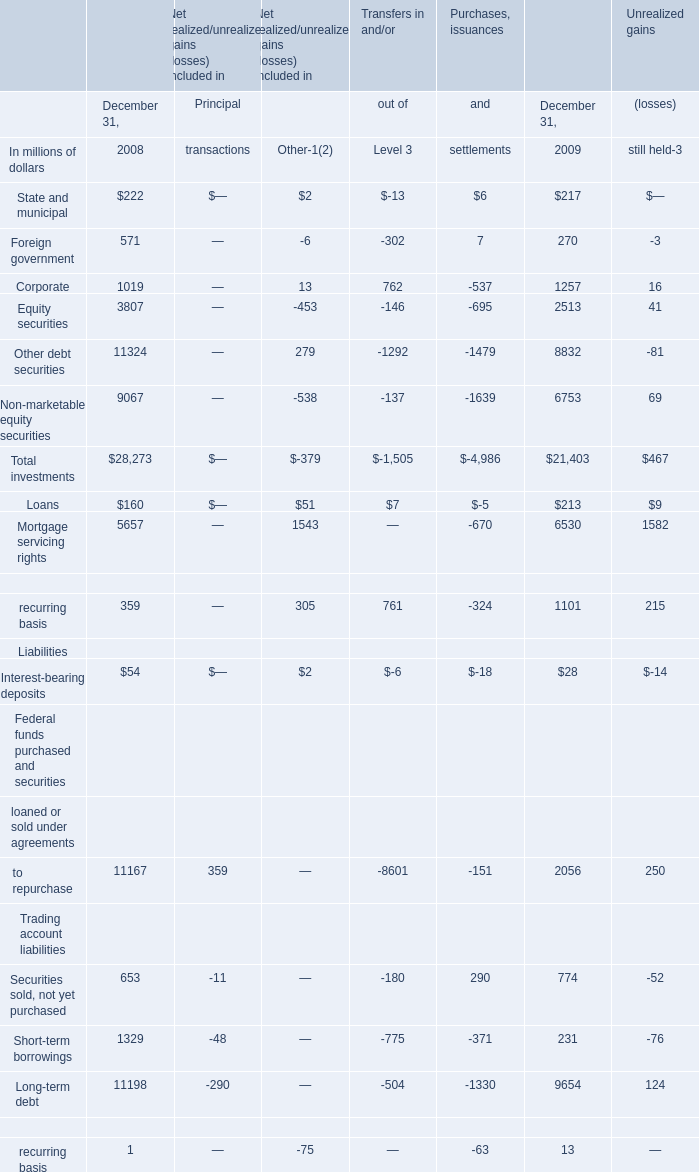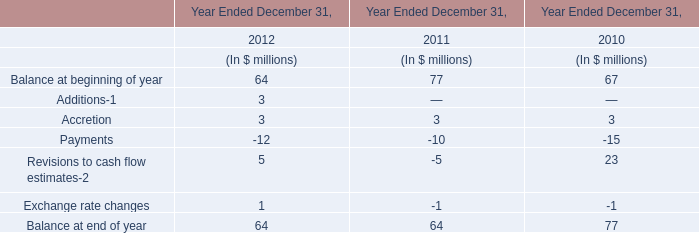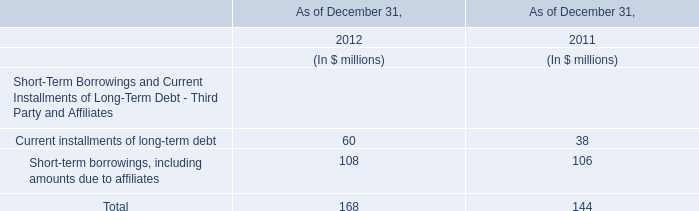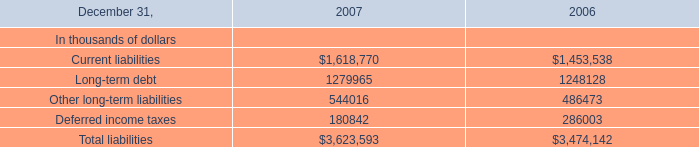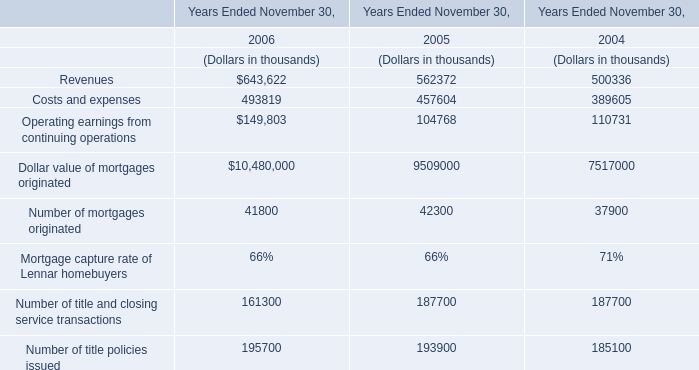What's the sum of Current liabilities of 2007, and Other debt securities of Unrealized gains December 31, 2009 ? 
Computations: (1618770.0 + 8832.0)
Answer: 1627602.0. 